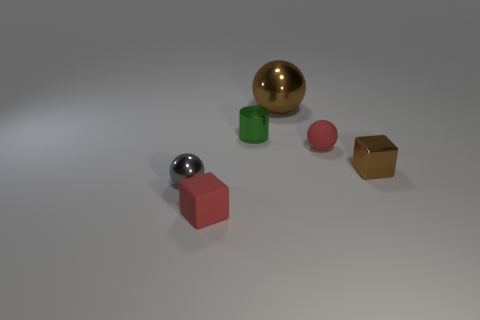What materials do these objects seem to be made of? The objects in the image appear to be made of different materials. The small red block looks to be rubbery, the tiny cylinder seems metallic, the sphere has a shiny surface suggesting it's metallic as well, the pink sphere could be plastic, and the golden cuboid might be made of a polished metal or a metal-like material. 